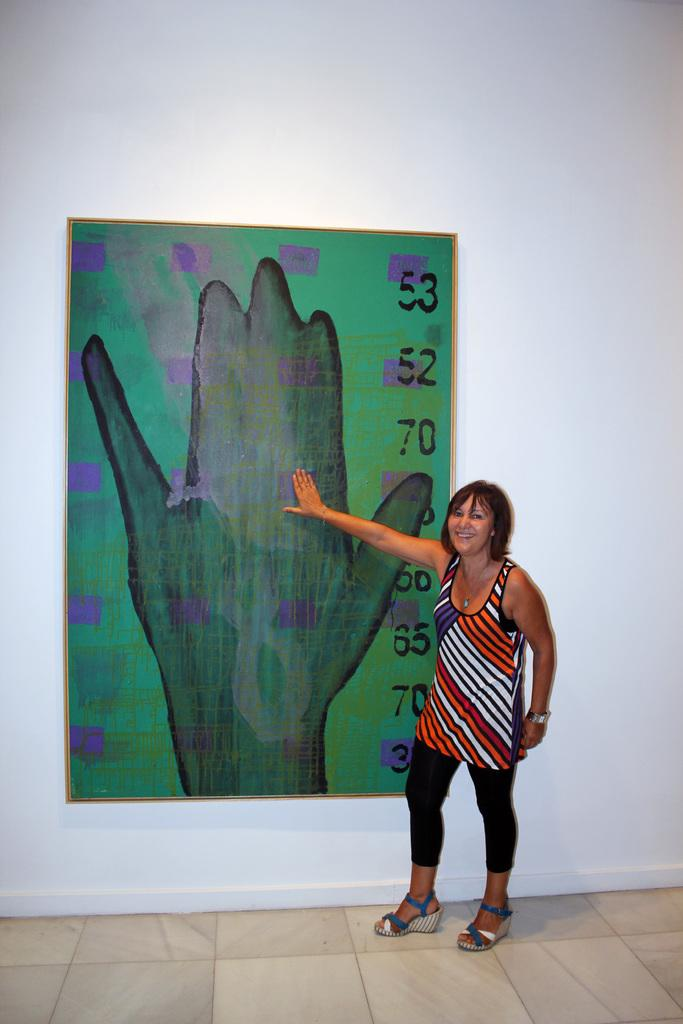Who is the main subject in the image? There is a lady in the image. What is the lady doing in the image? The lady is standing on the floor and touching a frame on the wall. What is inside the frame? There is a painting in the frame. What is depicted in the painting? The painting depicts a hand and numbers. What type of polish is the lady applying to the painting in the image? There is no indication in the image that the lady is applying any polish to the painting. What experience does the owner of the painting have? The image does not provide any information about the owner of the painting or their experience. 